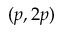Convert formula to latex. <formula><loc_0><loc_0><loc_500><loc_500>( p , 2 p )</formula> 